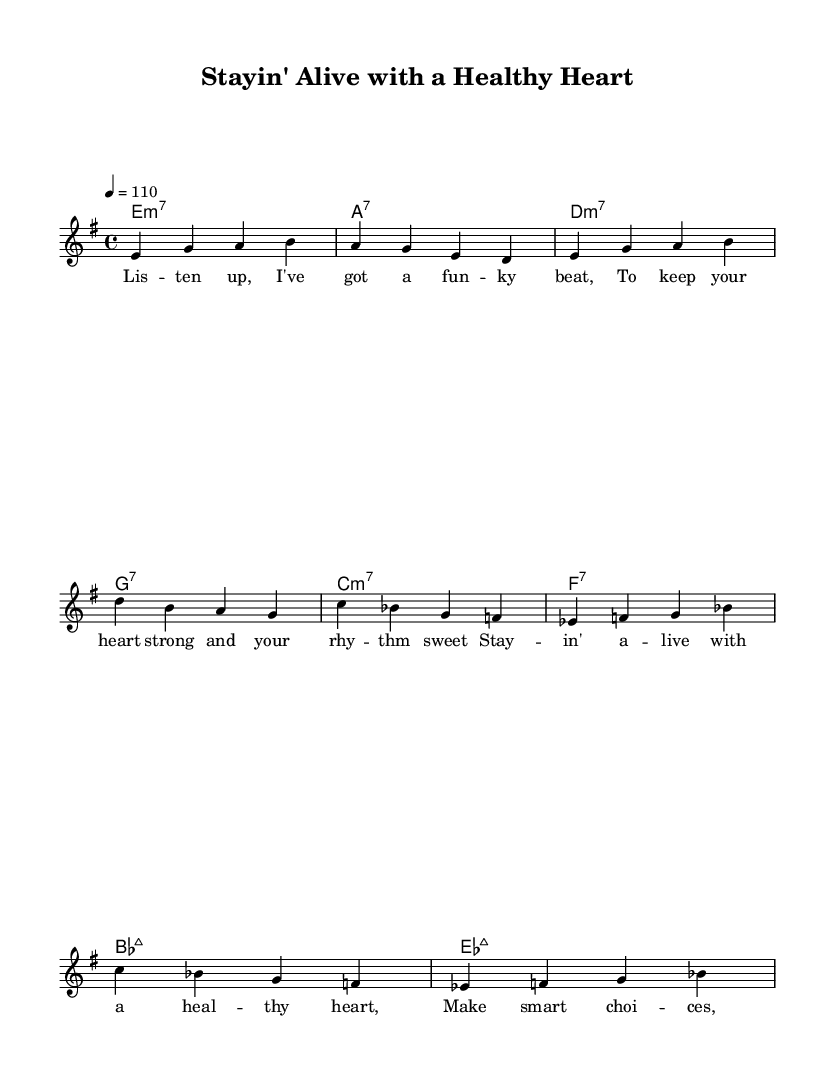What is the key signature of this music? The key signature is E minor, which has one sharp (F#). This can be identified by looking at the sharp symbols placed on the staff.
Answer: E minor What is the time signature of this music? The time signature is 4/4, indicated by the "4" over the "4" at the beginning of the score. This means there are four beats per measure and a quarter note gets one beat.
Answer: 4/4 What is the tempo marking for this piece? The tempo marking is 110 beats per minute, indicated by "4 = 110". This means that the quarter note should be played at a speed of 110 beats in one minute.
Answer: 110 How many measures are in the chorus? The chorus consists of four measures, which can be counted by looking at the number of groupings of the notes and the chord changes within the chorus section.
Answer: 4 Which chord comes first in the verse? The first chord in the verse is E minor 7, identified by the chord notation "e1:m7" placed above the staff at the start of the verse section.
Answer: E minor 7 What is the structure of the song? The structure consists of a verse followed by a chorus, repeated, indicated by the layout of the music and the presence of repeated sections in the lyrics and chord progressions.
Answer: Verse-Chorus What is the main theme of the lyrics? The main theme of the lyrics focuses on staying healthy and making smart choices for heart health, as indicated by the words in the verse and chorus emphasizing heart strength and choices.
Answer: Heart health 